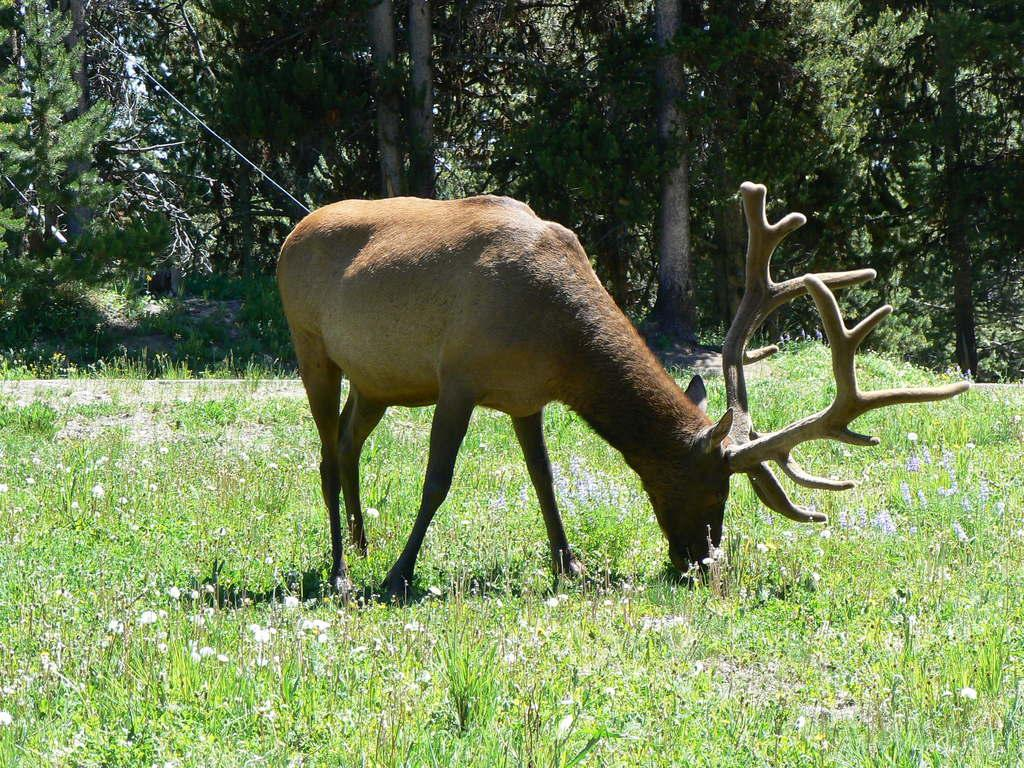What is the main subject in the center of the image? There is an animal in the center of the image. What can be seen in the background of the image? There are trees in the background of the image. What is visible at the bottom of the image? The ground is visible at the bottom of the image. What type of vegetation covers the ground? The ground is covered with grass. What type of straw is being used by the animal in the image? There is no straw present in the image, and the animal is not using any straw. 